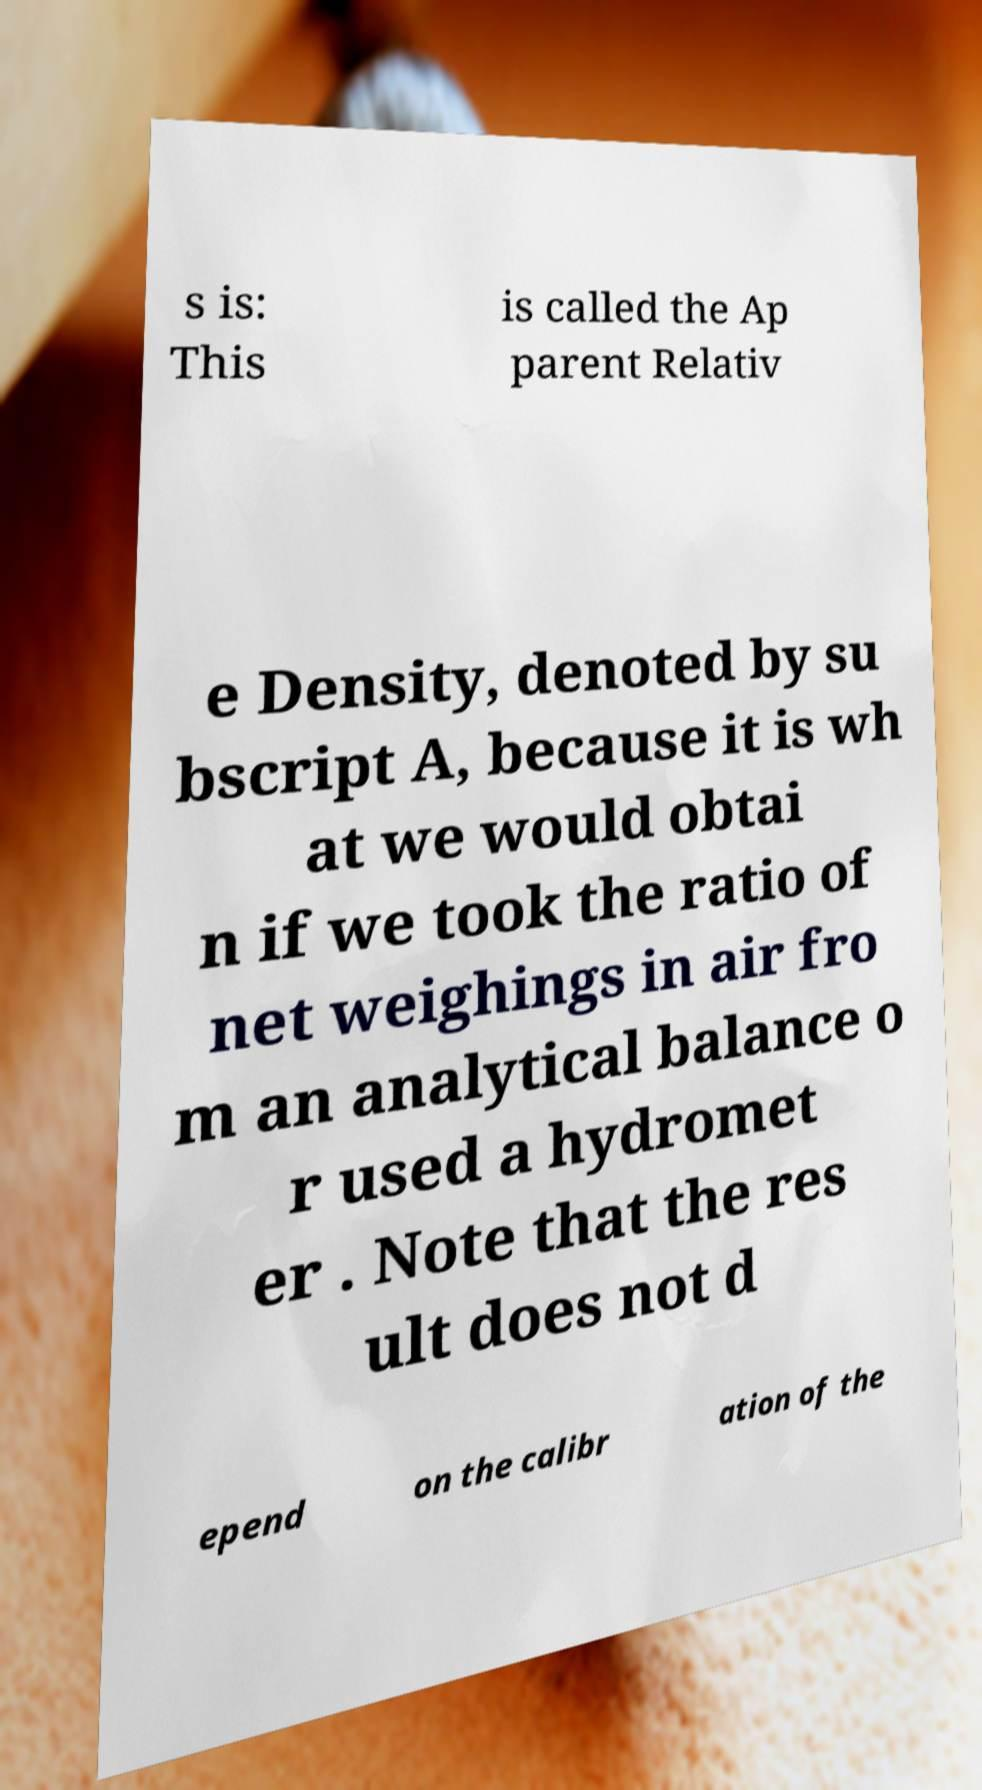Can you accurately transcribe the text from the provided image for me? s is: This is called the Ap parent Relativ e Density, denoted by su bscript A, because it is wh at we would obtai n if we took the ratio of net weighings in air fro m an analytical balance o r used a hydromet er . Note that the res ult does not d epend on the calibr ation of the 